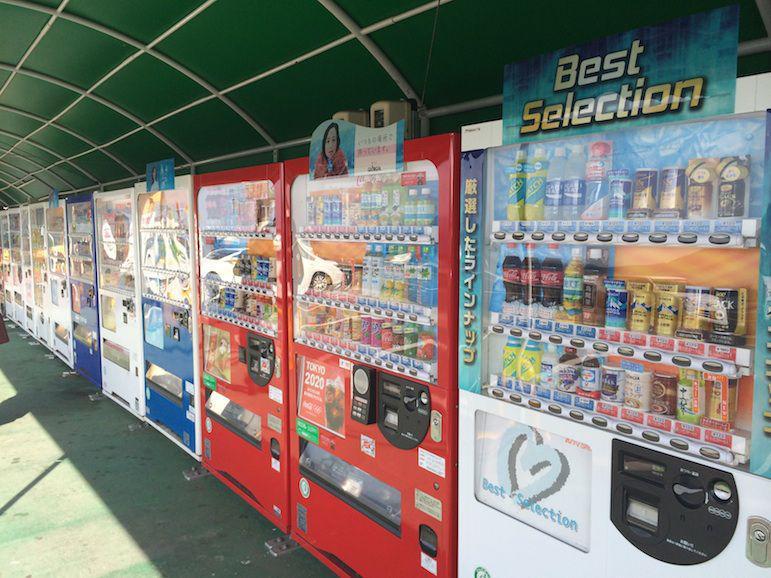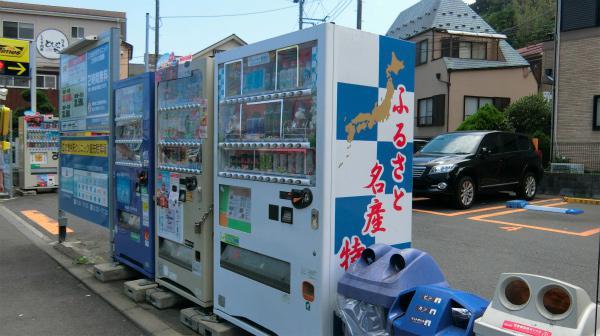The first image is the image on the left, the second image is the image on the right. Evaluate the accuracy of this statement regarding the images: "In one image, trash containers are sitting beside a vending machine.". Is it true? Answer yes or no. Yes. The first image is the image on the left, the second image is the image on the right. Given the left and right images, does the statement "One image contains exactly one red vending machine." hold true? Answer yes or no. No. 